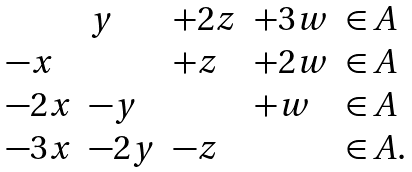<formula> <loc_0><loc_0><loc_500><loc_500>\begin{array} { l l l l l } & y & + 2 z & + 3 w & \in A \\ - x & & + z & + 2 w & \in A \\ - 2 x & - y & & + w & \in A \\ - 3 x & - 2 y & - z & & \in A . \end{array}</formula> 